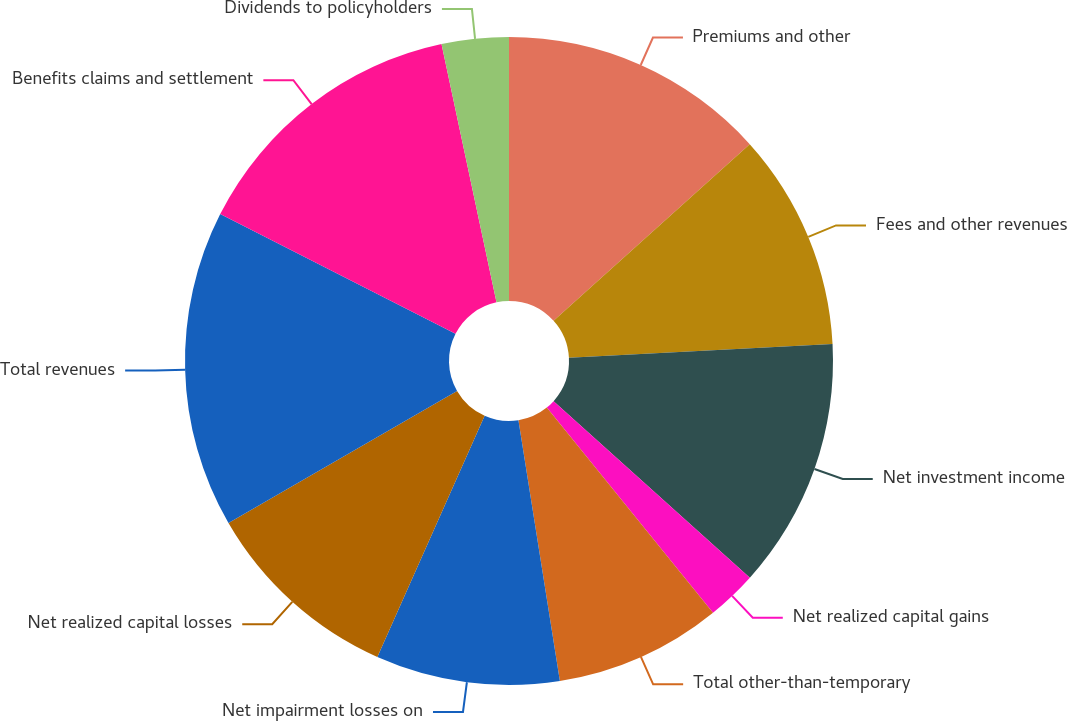Convert chart to OTSL. <chart><loc_0><loc_0><loc_500><loc_500><pie_chart><fcel>Premiums and other<fcel>Fees and other revenues<fcel>Net investment income<fcel>Net realized capital gains<fcel>Total other-than-temporary<fcel>Net impairment losses on<fcel>Net realized capital losses<fcel>Total revenues<fcel>Benefits claims and settlement<fcel>Dividends to policyholders<nl><fcel>13.33%<fcel>10.83%<fcel>12.5%<fcel>2.5%<fcel>8.33%<fcel>9.17%<fcel>10.0%<fcel>15.83%<fcel>14.17%<fcel>3.34%<nl></chart> 